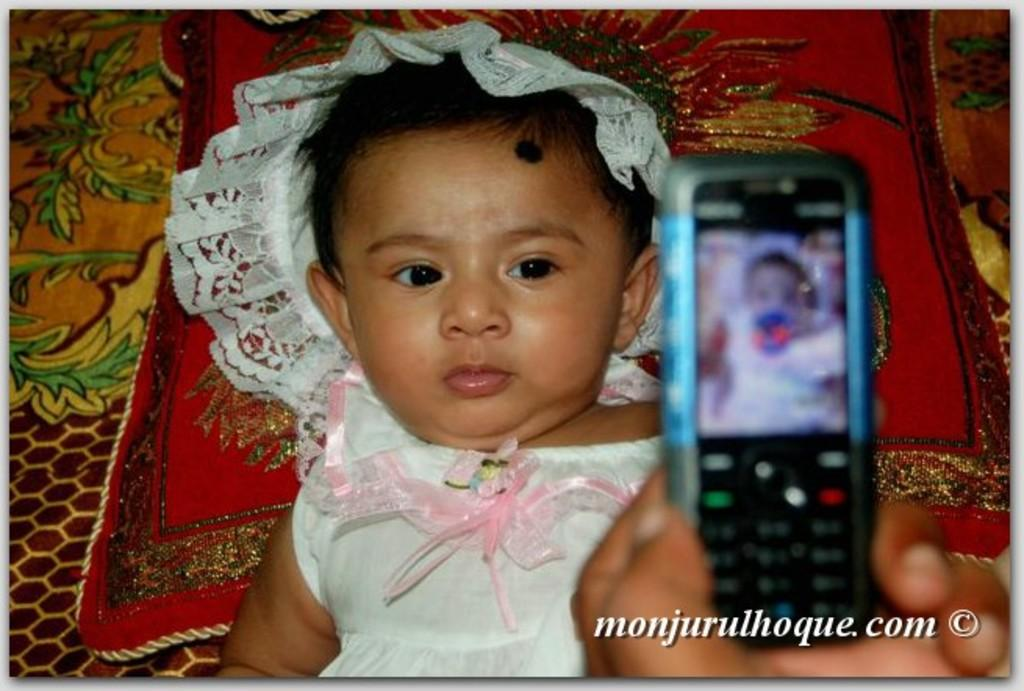What is the person in the image holding? The person is holding a mobile phone in the image. Can you describe the child's position in relation to the person holding the mobile phone? There is a child behind the mobile phone in the image. What type of furniture is present in the image? There is a pillow and a bed in the image. What type of cow can be seen grazing on the property in the image? There is no cow or property present in the image. What color is the coat worn by the person holding the mobile phone? The person holding the mobile phone is not wearing a coat in the image. 